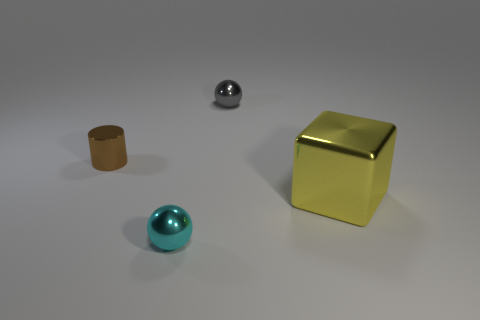What number of tiny objects are behind the big yellow metal block and in front of the brown cylinder?
Make the answer very short. 0. What is the large thing made of?
Provide a short and direct response. Metal. Are there any other things that are the same color as the tiny metal cylinder?
Your answer should be very brief. No. Are the gray object and the brown cylinder made of the same material?
Offer a very short reply. Yes. There is a shiny object to the right of the small object behind the small brown shiny object; what number of yellow shiny blocks are behind it?
Provide a succinct answer. 0. How many big blue metallic cylinders are there?
Give a very brief answer. 0. Is the number of things that are in front of the big yellow object less than the number of tiny brown objects that are in front of the brown shiny object?
Ensure brevity in your answer.  No. Is the number of brown metal things that are on the right side of the small cyan metal sphere less than the number of tiny shiny things?
Keep it short and to the point. Yes. What material is the sphere in front of the metallic sphere that is behind the ball in front of the brown shiny thing made of?
Offer a very short reply. Metal. What number of objects are things behind the big thing or shiny objects right of the tiny brown thing?
Keep it short and to the point. 4. 